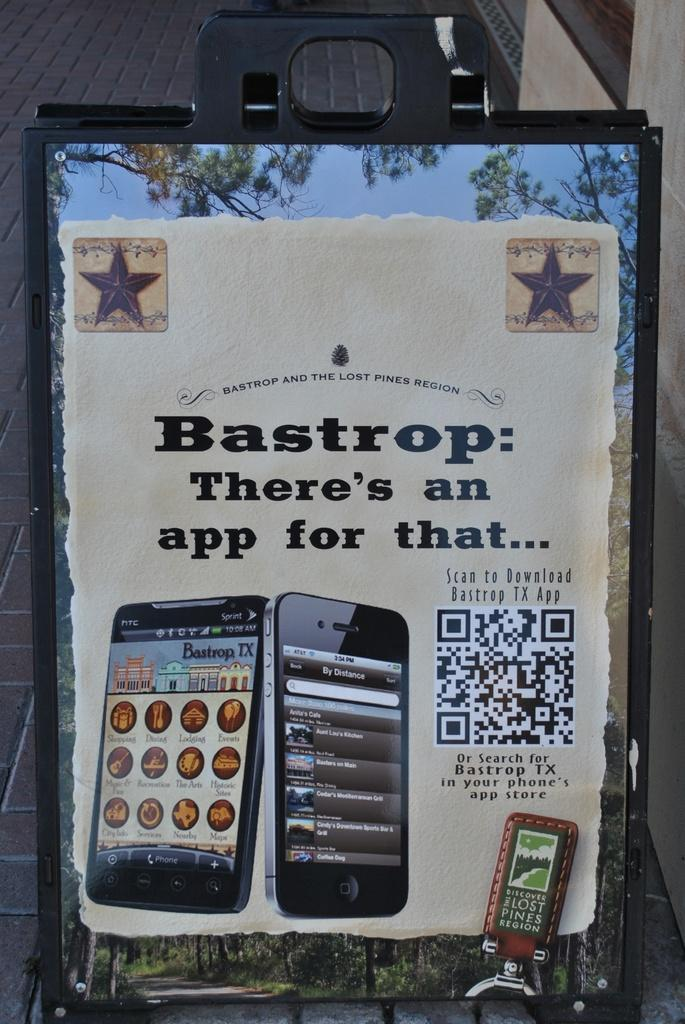What object is present in the image that can reflect images? There is a mirror in the image. What is placed on the mirror in the image? There is a poster on the mirror. What can be read or seen in the image? There is text visible in the image. What electronic devices are present in the image? There are mobile phones in the image. What type of natural scenery can be seen in the mirror? Trees are visible in the mirror. What part of the sky can be seen in the mirror? The sky is visible in the mirror. What type of plane can be seen flying in the mirror? There is no plane visible in the mirror; only trees and the sky are present. What is the mouth of the person in the mirror saying? There is no person present in the mirror, so there is no mouth to determine what it might be saying. 